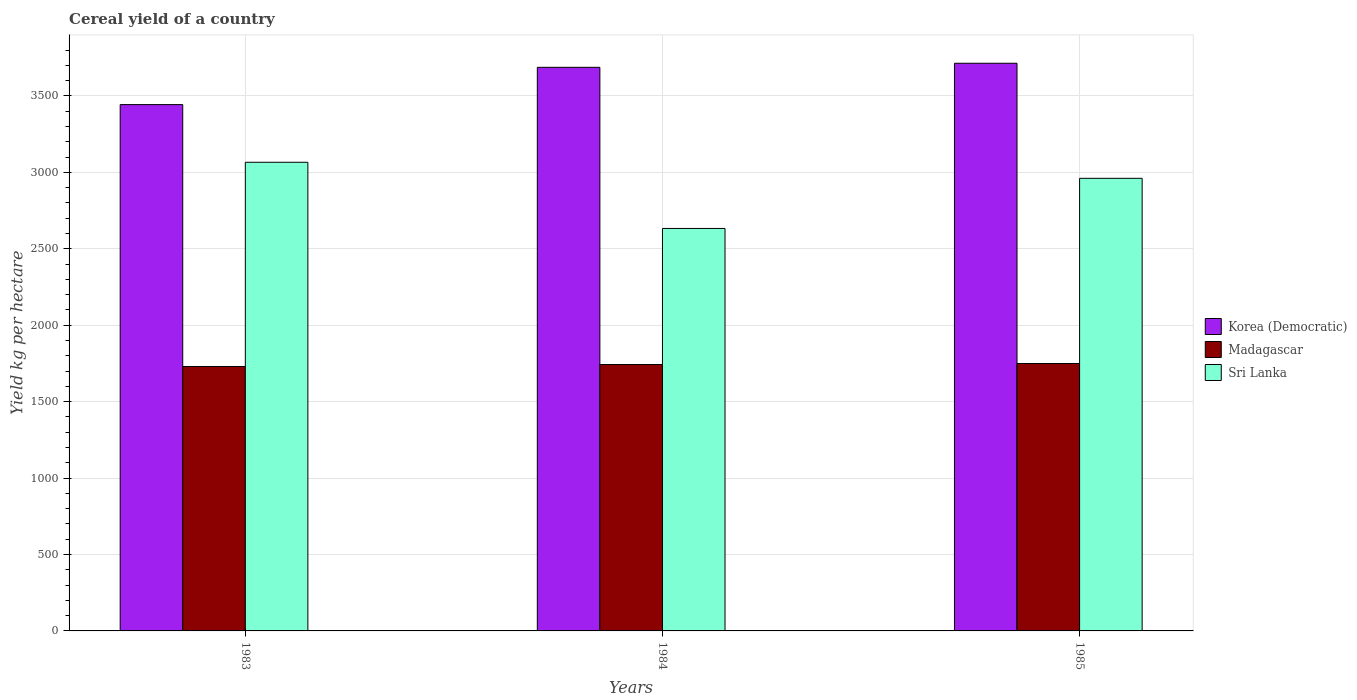How many different coloured bars are there?
Provide a short and direct response. 3. Are the number of bars on each tick of the X-axis equal?
Provide a succinct answer. Yes. How many bars are there on the 1st tick from the left?
Make the answer very short. 3. How many bars are there on the 3rd tick from the right?
Ensure brevity in your answer.  3. What is the label of the 3rd group of bars from the left?
Your response must be concise. 1985. In how many cases, is the number of bars for a given year not equal to the number of legend labels?
Make the answer very short. 0. What is the total cereal yield in Sri Lanka in 1984?
Your response must be concise. 2632.76. Across all years, what is the maximum total cereal yield in Madagascar?
Your answer should be compact. 1749.27. Across all years, what is the minimum total cereal yield in Sri Lanka?
Provide a short and direct response. 2632.76. What is the total total cereal yield in Madagascar in the graph?
Provide a short and direct response. 5221.52. What is the difference between the total cereal yield in Madagascar in 1983 and that in 1985?
Ensure brevity in your answer.  -19.58. What is the difference between the total cereal yield in Korea (Democratic) in 1985 and the total cereal yield in Sri Lanka in 1984?
Keep it short and to the point. 1080.53. What is the average total cereal yield in Madagascar per year?
Your answer should be compact. 1740.51. In the year 1983, what is the difference between the total cereal yield in Madagascar and total cereal yield in Korea (Democratic)?
Offer a very short reply. -1713.15. In how many years, is the total cereal yield in Madagascar greater than 3200 kg per hectare?
Keep it short and to the point. 0. What is the ratio of the total cereal yield in Sri Lanka in 1984 to that in 1985?
Give a very brief answer. 0.89. Is the total cereal yield in Sri Lanka in 1983 less than that in 1985?
Your response must be concise. No. Is the difference between the total cereal yield in Madagascar in 1983 and 1985 greater than the difference between the total cereal yield in Korea (Democratic) in 1983 and 1985?
Your answer should be very brief. Yes. What is the difference between the highest and the second highest total cereal yield in Korea (Democratic)?
Your answer should be compact. 26.58. What is the difference between the highest and the lowest total cereal yield in Sri Lanka?
Make the answer very short. 432.88. Is the sum of the total cereal yield in Korea (Democratic) in 1984 and 1985 greater than the maximum total cereal yield in Madagascar across all years?
Ensure brevity in your answer.  Yes. What does the 3rd bar from the left in 1985 represents?
Keep it short and to the point. Sri Lanka. What does the 3rd bar from the right in 1983 represents?
Offer a very short reply. Korea (Democratic). Is it the case that in every year, the sum of the total cereal yield in Madagascar and total cereal yield in Korea (Democratic) is greater than the total cereal yield in Sri Lanka?
Offer a terse response. Yes. Are all the bars in the graph horizontal?
Keep it short and to the point. No. How many years are there in the graph?
Keep it short and to the point. 3. What is the difference between two consecutive major ticks on the Y-axis?
Provide a succinct answer. 500. Are the values on the major ticks of Y-axis written in scientific E-notation?
Ensure brevity in your answer.  No. Does the graph contain grids?
Your answer should be very brief. Yes. How are the legend labels stacked?
Make the answer very short. Vertical. What is the title of the graph?
Make the answer very short. Cereal yield of a country. What is the label or title of the X-axis?
Offer a terse response. Years. What is the label or title of the Y-axis?
Provide a succinct answer. Yield kg per hectare. What is the Yield kg per hectare in Korea (Democratic) in 1983?
Offer a terse response. 3442.84. What is the Yield kg per hectare in Madagascar in 1983?
Keep it short and to the point. 1729.68. What is the Yield kg per hectare in Sri Lanka in 1983?
Make the answer very short. 3065.64. What is the Yield kg per hectare in Korea (Democratic) in 1984?
Provide a short and direct response. 3686.71. What is the Yield kg per hectare in Madagascar in 1984?
Your response must be concise. 1742.57. What is the Yield kg per hectare in Sri Lanka in 1984?
Ensure brevity in your answer.  2632.76. What is the Yield kg per hectare of Korea (Democratic) in 1985?
Keep it short and to the point. 3713.29. What is the Yield kg per hectare of Madagascar in 1985?
Offer a terse response. 1749.27. What is the Yield kg per hectare in Sri Lanka in 1985?
Offer a very short reply. 2960.59. Across all years, what is the maximum Yield kg per hectare in Korea (Democratic)?
Offer a very short reply. 3713.29. Across all years, what is the maximum Yield kg per hectare of Madagascar?
Provide a short and direct response. 1749.27. Across all years, what is the maximum Yield kg per hectare of Sri Lanka?
Offer a terse response. 3065.64. Across all years, what is the minimum Yield kg per hectare of Korea (Democratic)?
Offer a terse response. 3442.84. Across all years, what is the minimum Yield kg per hectare in Madagascar?
Your answer should be very brief. 1729.68. Across all years, what is the minimum Yield kg per hectare of Sri Lanka?
Make the answer very short. 2632.76. What is the total Yield kg per hectare of Korea (Democratic) in the graph?
Your answer should be very brief. 1.08e+04. What is the total Yield kg per hectare of Madagascar in the graph?
Provide a succinct answer. 5221.52. What is the total Yield kg per hectare in Sri Lanka in the graph?
Your response must be concise. 8658.98. What is the difference between the Yield kg per hectare of Korea (Democratic) in 1983 and that in 1984?
Give a very brief answer. -243.87. What is the difference between the Yield kg per hectare in Madagascar in 1983 and that in 1984?
Provide a short and direct response. -12.88. What is the difference between the Yield kg per hectare in Sri Lanka in 1983 and that in 1984?
Provide a succinct answer. 432.88. What is the difference between the Yield kg per hectare of Korea (Democratic) in 1983 and that in 1985?
Provide a short and direct response. -270.45. What is the difference between the Yield kg per hectare of Madagascar in 1983 and that in 1985?
Provide a succinct answer. -19.58. What is the difference between the Yield kg per hectare in Sri Lanka in 1983 and that in 1985?
Offer a very short reply. 105.05. What is the difference between the Yield kg per hectare of Korea (Democratic) in 1984 and that in 1985?
Give a very brief answer. -26.58. What is the difference between the Yield kg per hectare in Madagascar in 1984 and that in 1985?
Your response must be concise. -6.7. What is the difference between the Yield kg per hectare in Sri Lanka in 1984 and that in 1985?
Your response must be concise. -327.83. What is the difference between the Yield kg per hectare of Korea (Democratic) in 1983 and the Yield kg per hectare of Madagascar in 1984?
Your answer should be compact. 1700.27. What is the difference between the Yield kg per hectare of Korea (Democratic) in 1983 and the Yield kg per hectare of Sri Lanka in 1984?
Your response must be concise. 810.08. What is the difference between the Yield kg per hectare in Madagascar in 1983 and the Yield kg per hectare in Sri Lanka in 1984?
Your answer should be compact. -903.07. What is the difference between the Yield kg per hectare of Korea (Democratic) in 1983 and the Yield kg per hectare of Madagascar in 1985?
Give a very brief answer. 1693.57. What is the difference between the Yield kg per hectare in Korea (Democratic) in 1983 and the Yield kg per hectare in Sri Lanka in 1985?
Your answer should be very brief. 482.25. What is the difference between the Yield kg per hectare of Madagascar in 1983 and the Yield kg per hectare of Sri Lanka in 1985?
Your answer should be very brief. -1230.9. What is the difference between the Yield kg per hectare in Korea (Democratic) in 1984 and the Yield kg per hectare in Madagascar in 1985?
Give a very brief answer. 1937.44. What is the difference between the Yield kg per hectare of Korea (Democratic) in 1984 and the Yield kg per hectare of Sri Lanka in 1985?
Your response must be concise. 726.12. What is the difference between the Yield kg per hectare of Madagascar in 1984 and the Yield kg per hectare of Sri Lanka in 1985?
Offer a very short reply. -1218.02. What is the average Yield kg per hectare of Korea (Democratic) per year?
Give a very brief answer. 3614.28. What is the average Yield kg per hectare of Madagascar per year?
Keep it short and to the point. 1740.51. What is the average Yield kg per hectare of Sri Lanka per year?
Your response must be concise. 2886.33. In the year 1983, what is the difference between the Yield kg per hectare in Korea (Democratic) and Yield kg per hectare in Madagascar?
Keep it short and to the point. 1713.15. In the year 1983, what is the difference between the Yield kg per hectare of Korea (Democratic) and Yield kg per hectare of Sri Lanka?
Your response must be concise. 377.2. In the year 1983, what is the difference between the Yield kg per hectare in Madagascar and Yield kg per hectare in Sri Lanka?
Give a very brief answer. -1335.95. In the year 1984, what is the difference between the Yield kg per hectare of Korea (Democratic) and Yield kg per hectare of Madagascar?
Provide a succinct answer. 1944.14. In the year 1984, what is the difference between the Yield kg per hectare of Korea (Democratic) and Yield kg per hectare of Sri Lanka?
Offer a very short reply. 1053.95. In the year 1984, what is the difference between the Yield kg per hectare in Madagascar and Yield kg per hectare in Sri Lanka?
Offer a terse response. -890.19. In the year 1985, what is the difference between the Yield kg per hectare in Korea (Democratic) and Yield kg per hectare in Madagascar?
Keep it short and to the point. 1964.02. In the year 1985, what is the difference between the Yield kg per hectare in Korea (Democratic) and Yield kg per hectare in Sri Lanka?
Make the answer very short. 752.7. In the year 1985, what is the difference between the Yield kg per hectare of Madagascar and Yield kg per hectare of Sri Lanka?
Your answer should be very brief. -1211.32. What is the ratio of the Yield kg per hectare in Korea (Democratic) in 1983 to that in 1984?
Your response must be concise. 0.93. What is the ratio of the Yield kg per hectare in Sri Lanka in 1983 to that in 1984?
Provide a short and direct response. 1.16. What is the ratio of the Yield kg per hectare in Korea (Democratic) in 1983 to that in 1985?
Provide a short and direct response. 0.93. What is the ratio of the Yield kg per hectare in Madagascar in 1983 to that in 1985?
Provide a short and direct response. 0.99. What is the ratio of the Yield kg per hectare in Sri Lanka in 1983 to that in 1985?
Your answer should be compact. 1.04. What is the ratio of the Yield kg per hectare in Korea (Democratic) in 1984 to that in 1985?
Your answer should be compact. 0.99. What is the ratio of the Yield kg per hectare in Madagascar in 1984 to that in 1985?
Give a very brief answer. 1. What is the ratio of the Yield kg per hectare in Sri Lanka in 1984 to that in 1985?
Give a very brief answer. 0.89. What is the difference between the highest and the second highest Yield kg per hectare of Korea (Democratic)?
Your answer should be compact. 26.58. What is the difference between the highest and the second highest Yield kg per hectare in Madagascar?
Give a very brief answer. 6.7. What is the difference between the highest and the second highest Yield kg per hectare of Sri Lanka?
Give a very brief answer. 105.05. What is the difference between the highest and the lowest Yield kg per hectare in Korea (Democratic)?
Offer a terse response. 270.45. What is the difference between the highest and the lowest Yield kg per hectare in Madagascar?
Your answer should be very brief. 19.58. What is the difference between the highest and the lowest Yield kg per hectare in Sri Lanka?
Your response must be concise. 432.88. 